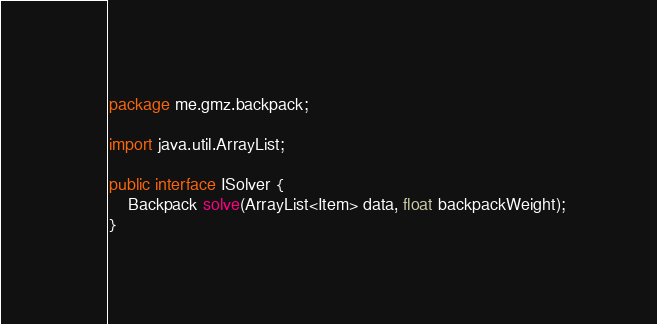<code> <loc_0><loc_0><loc_500><loc_500><_Java_>package me.gmz.backpack;

import java.util.ArrayList;

public interface ISolver {
    Backpack solve(ArrayList<Item> data, float backpackWeight);
}
</code> 